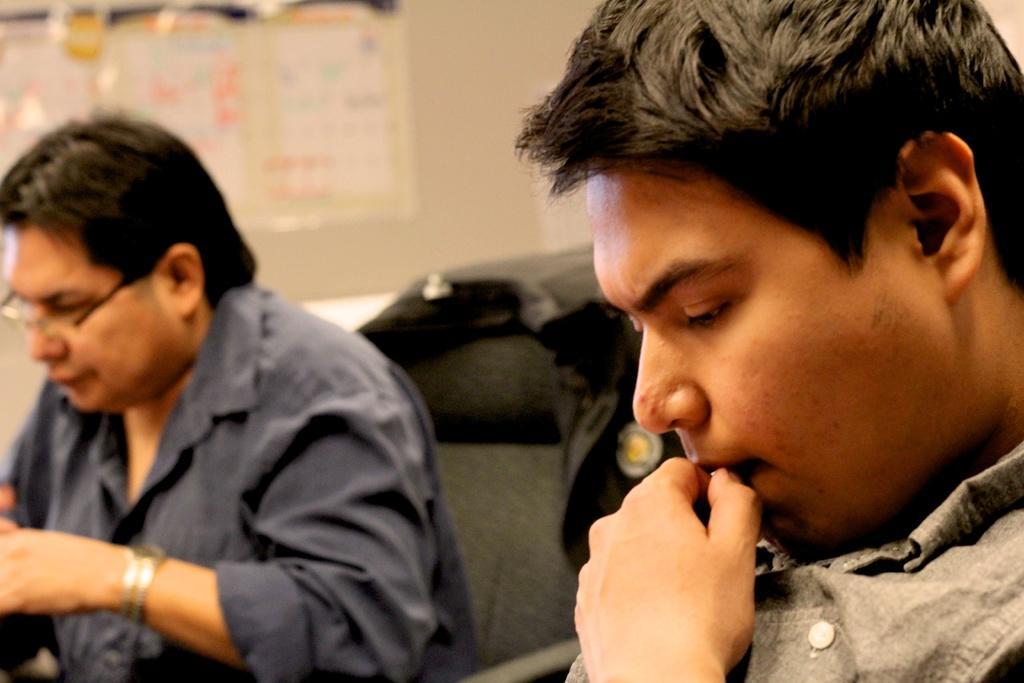How would you summarize this image in a sentence or two? In this image, we can see two people. On the right side of the image, we can see a person keeping her fingers near to the mouth. Here a person is sitting on a chair. Background we can see wall and some objects. 